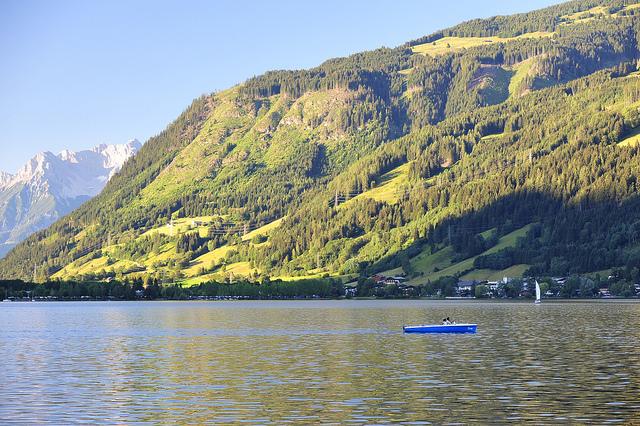Are there any mountains in the picture?
Answer briefly. Yes. Is it a sunny day?
Quick response, please. Yes. Are there any boats on the water?
Be succinct. Yes. 